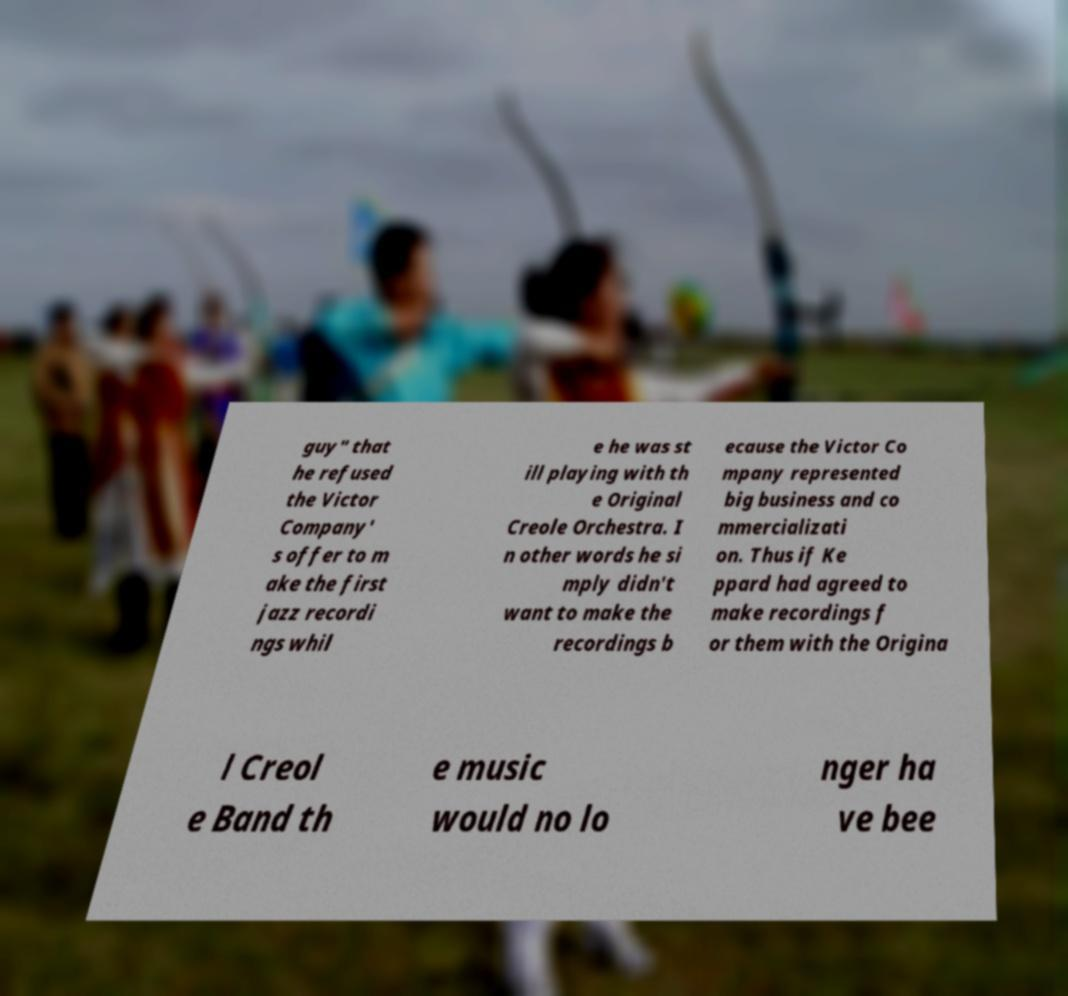Could you assist in decoding the text presented in this image and type it out clearly? guy" that he refused the Victor Company' s offer to m ake the first jazz recordi ngs whil e he was st ill playing with th e Original Creole Orchestra. I n other words he si mply didn't want to make the recordings b ecause the Victor Co mpany represented big business and co mmercializati on. Thus if Ke ppard had agreed to make recordings f or them with the Origina l Creol e Band th e music would no lo nger ha ve bee 